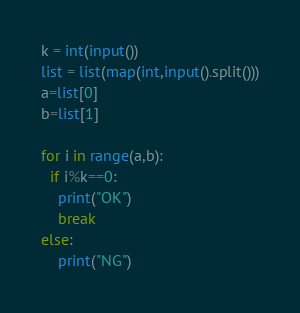Convert code to text. <code><loc_0><loc_0><loc_500><loc_500><_Python_>k = int(input())
list = list(map(int,input().split()))
a=list[0]
b=list[1]

for i in range(a,b):
  if i%k==0:
    print("OK")
    break
else:
    print("NG")

</code> 